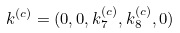Convert formula to latex. <formula><loc_0><loc_0><loc_500><loc_500>k ^ { ( c ) } = ( 0 , 0 , k _ { 7 } ^ { ( c ) } , k _ { 8 } ^ { ( c ) } , 0 )</formula> 